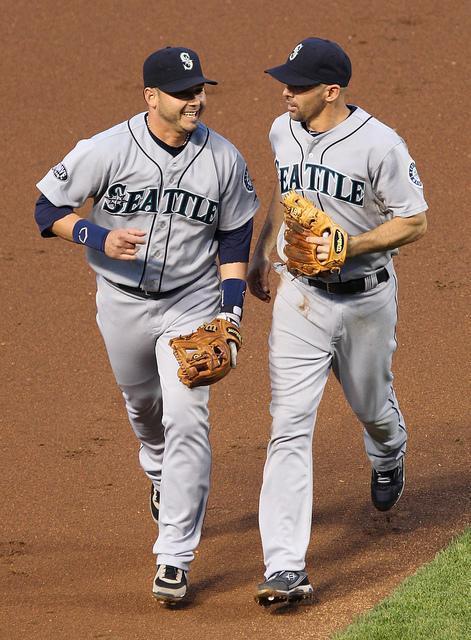How many baseball gloves are there?
Give a very brief answer. 2. How many people can be seen?
Give a very brief answer. 2. How many elephants are in this scene?
Give a very brief answer. 0. 